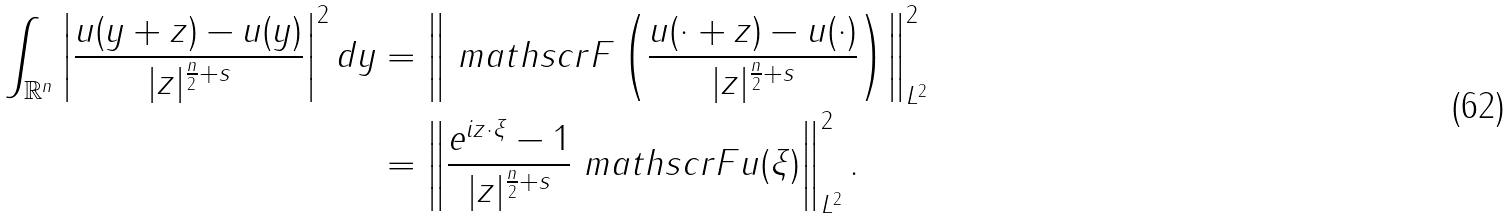<formula> <loc_0><loc_0><loc_500><loc_500>\int _ { \mathbb { R } ^ { n } } \left | \frac { u ( y + z ) - u ( y ) } { | z | ^ { \frac { n } { 2 } + s } } \right | ^ { 2 } d y & = \left \| \ m a t h s c r { F } \left ( \frac { u ( \cdot + z ) - u ( \cdot ) } { | z | ^ { \frac { n } { 2 } + s } } \right ) \right \| _ { L ^ { 2 } } ^ { 2 } \\ & = \left \| \frac { e ^ { i z \cdot \xi } - 1 } { | z | ^ { \frac { n } { 2 } + s } } \ m a t h s c r { F } u ( \xi ) \right \| _ { L ^ { 2 } } ^ { 2 } .</formula> 